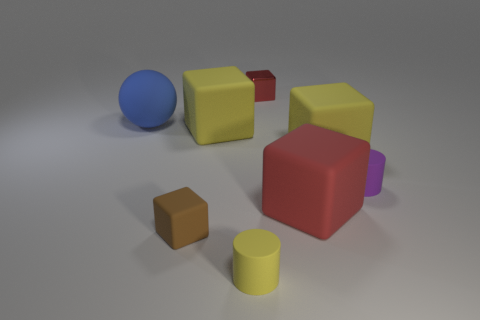Is there any other thing that is the same material as the tiny red block?
Ensure brevity in your answer.  No. There is a purple rubber cylinder; is its size the same as the cylinder that is on the left side of the tiny red block?
Offer a very short reply. Yes. There is a small block on the right side of the yellow thing in front of the tiny purple object; what is it made of?
Provide a succinct answer. Metal. Is the number of large blue objects on the right side of the large red object the same as the number of large red matte cylinders?
Offer a terse response. Yes. What is the size of the matte block that is both to the left of the metal block and behind the small purple object?
Provide a succinct answer. Large. The small cylinder that is behind the rubber cylinder in front of the small purple rubber object is what color?
Your answer should be compact. Purple. How many purple things are either tiny rubber cylinders or big matte cubes?
Your answer should be compact. 1. There is a large matte thing that is left of the large red matte cube and in front of the sphere; what is its color?
Offer a terse response. Yellow. What number of small things are red metal objects or brown rubber blocks?
Provide a succinct answer. 2. There is a brown rubber thing that is the same shape as the red shiny thing; what is its size?
Ensure brevity in your answer.  Small. 